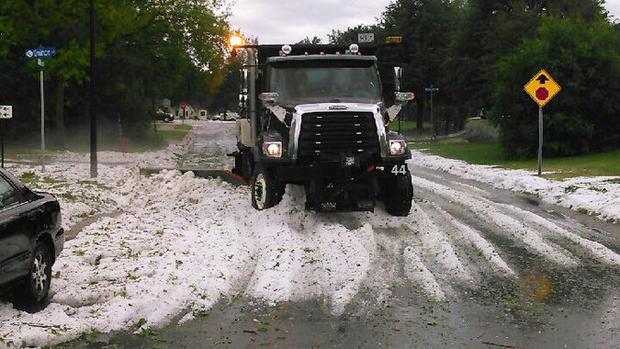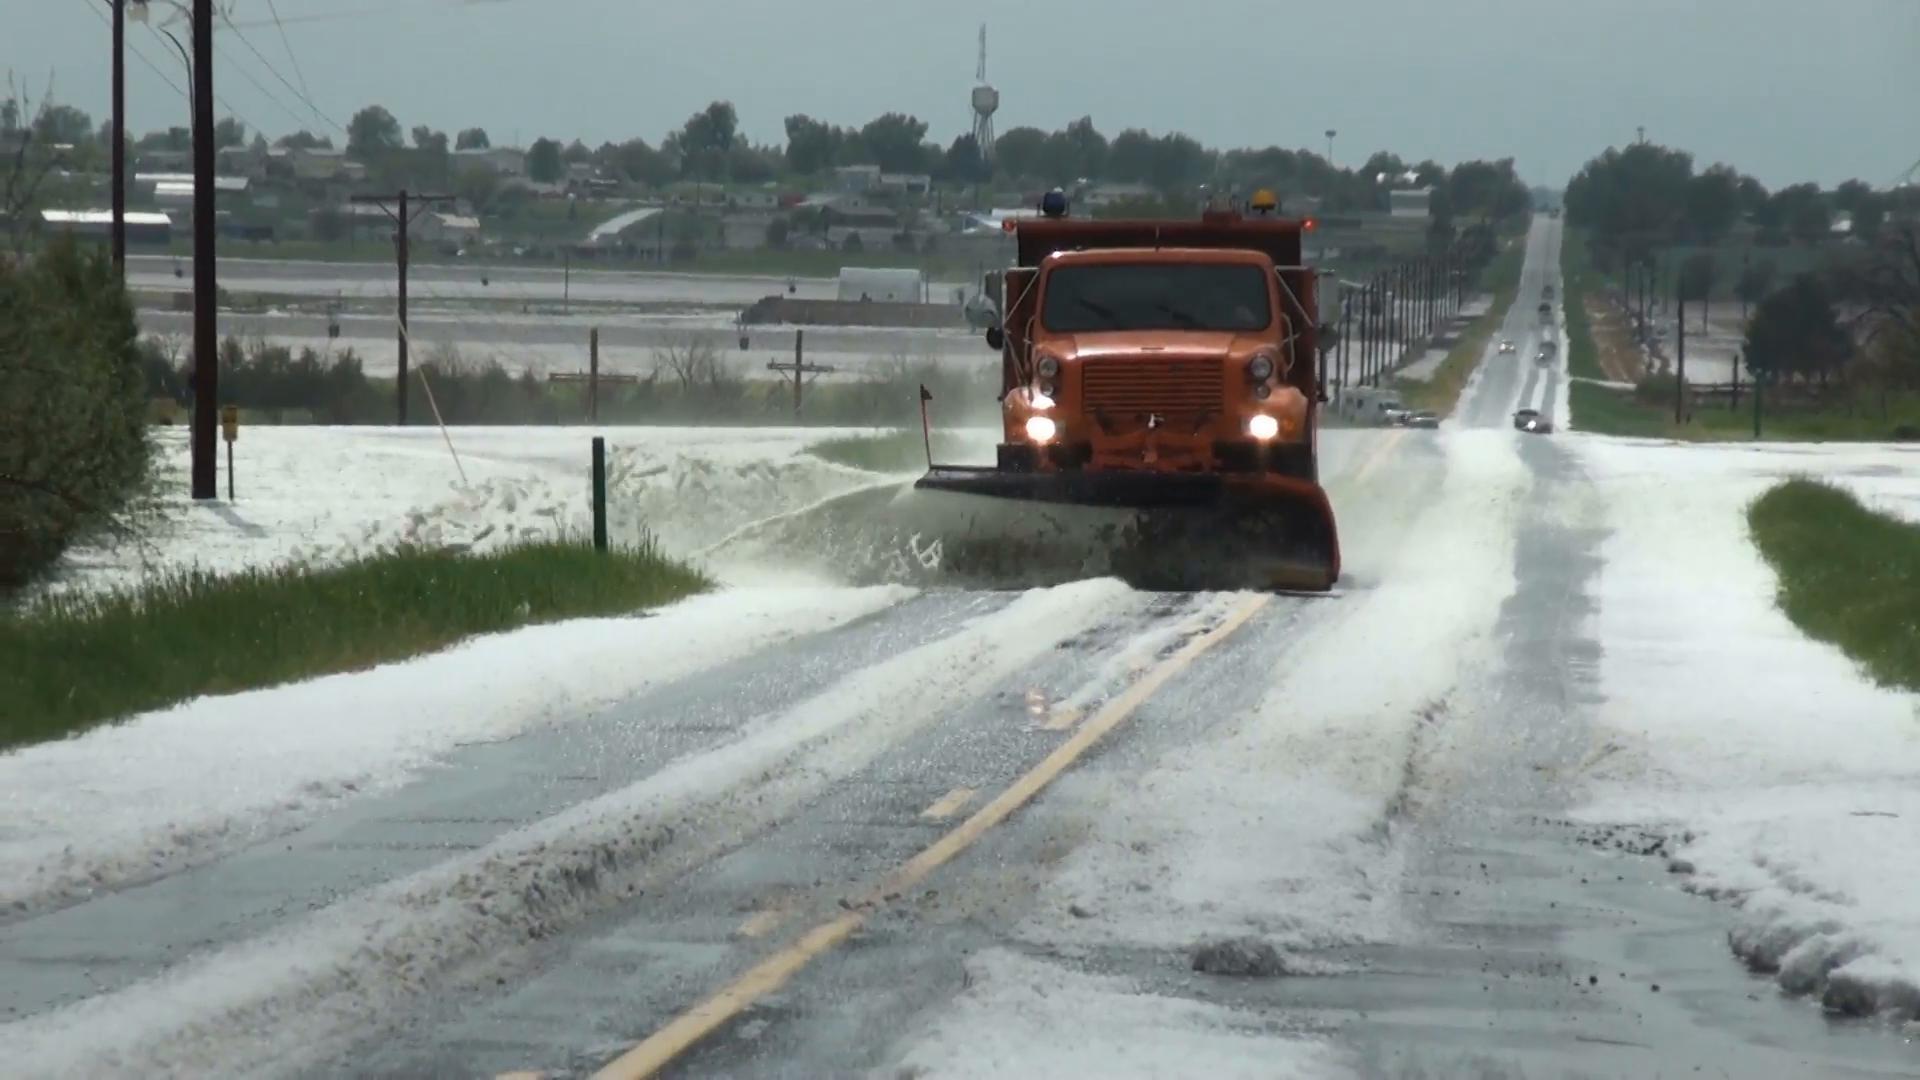The first image is the image on the left, the second image is the image on the right. Given the left and right images, does the statement "In the right image a snow plow is plowing snow." hold true? Answer yes or no. Yes. 